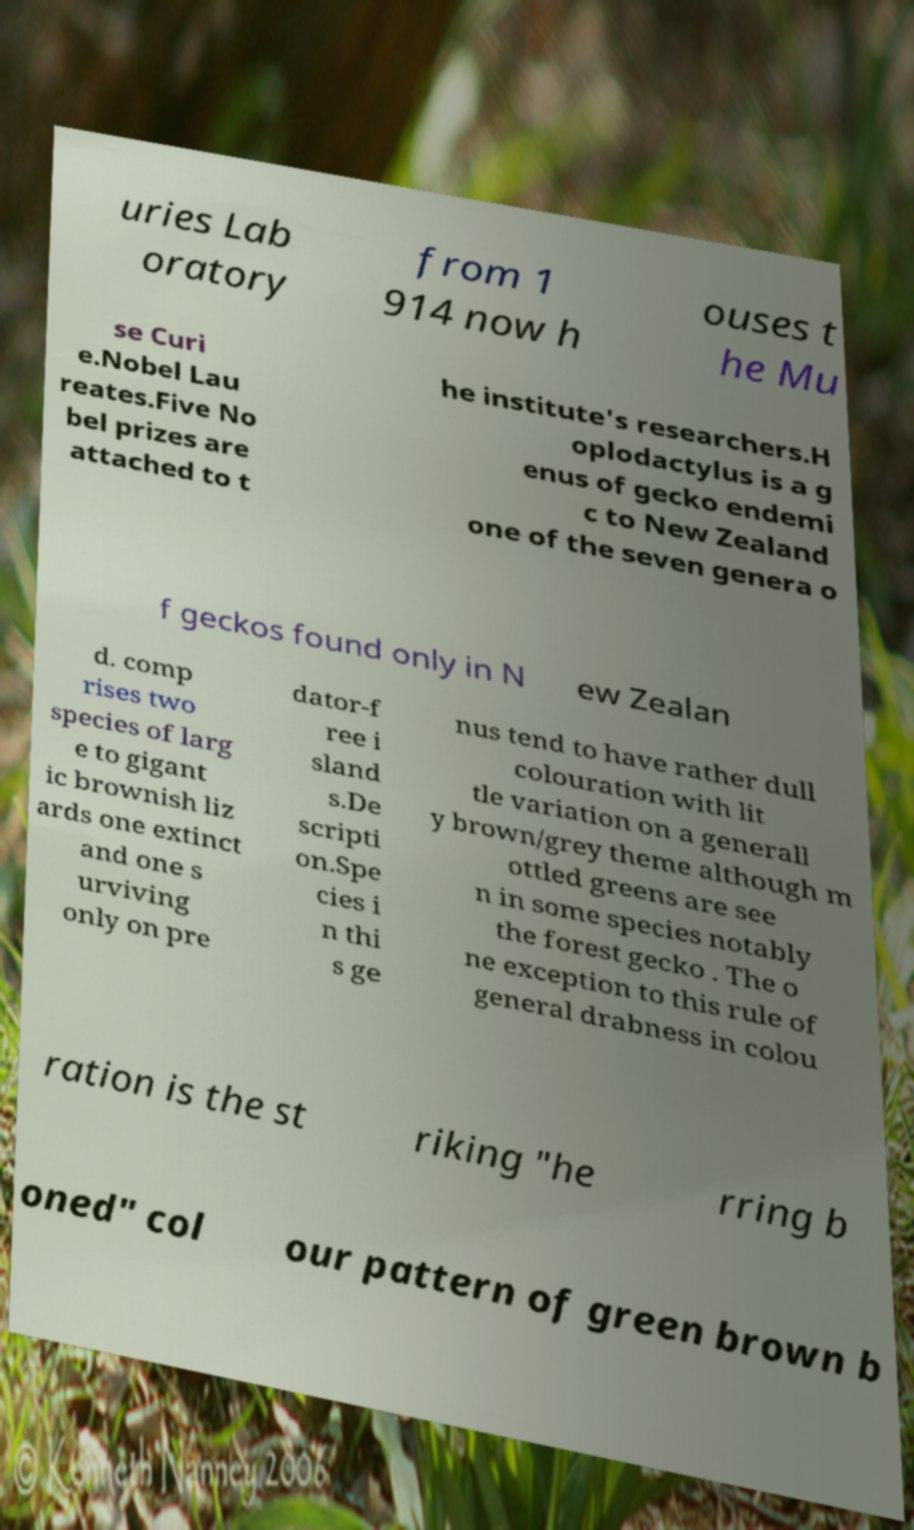Can you accurately transcribe the text from the provided image for me? uries Lab oratory from 1 914 now h ouses t he Mu se Curi e.Nobel Lau reates.Five No bel prizes are attached to t he institute's researchers.H oplodactylus is a g enus of gecko endemi c to New Zealand one of the seven genera o f geckos found only in N ew Zealan d. comp rises two species of larg e to gigant ic brownish liz ards one extinct and one s urviving only on pre dator-f ree i sland s.De scripti on.Spe cies i n thi s ge nus tend to have rather dull colouration with lit tle variation on a generall y brown/grey theme although m ottled greens are see n in some species notably the forest gecko . The o ne exception to this rule of general drabness in colou ration is the st riking "he rring b oned" col our pattern of green brown b 